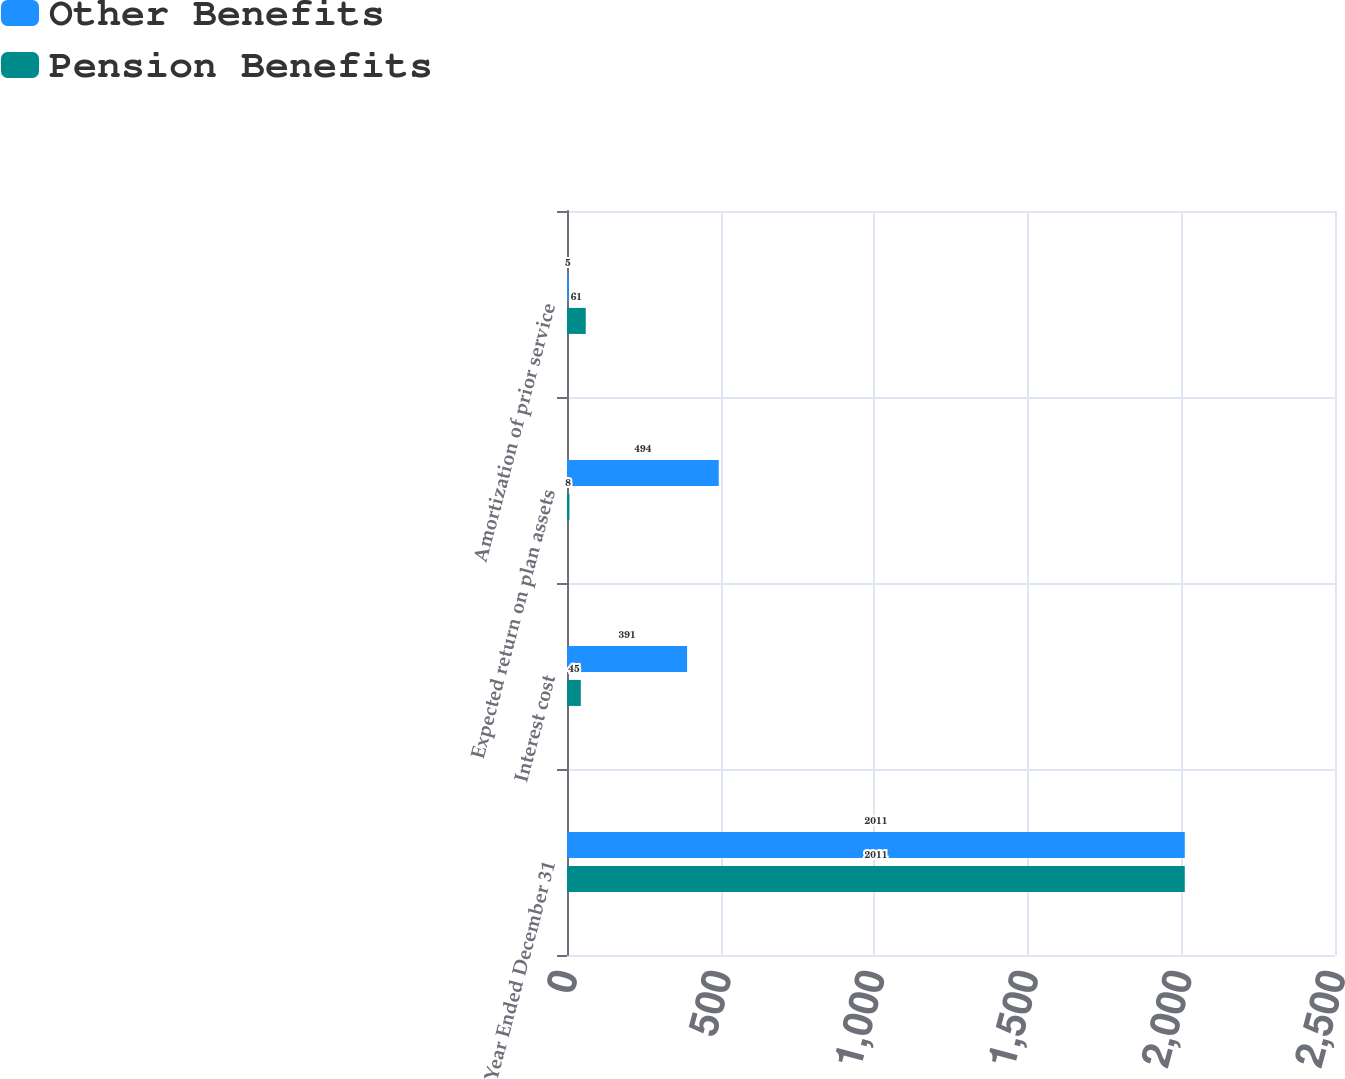Convert chart. <chart><loc_0><loc_0><loc_500><loc_500><stacked_bar_chart><ecel><fcel>Year Ended December 31<fcel>Interest cost<fcel>Expected return on plan assets<fcel>Amortization of prior service<nl><fcel>Other Benefits<fcel>2011<fcel>391<fcel>494<fcel>5<nl><fcel>Pension Benefits<fcel>2011<fcel>45<fcel>8<fcel>61<nl></chart> 